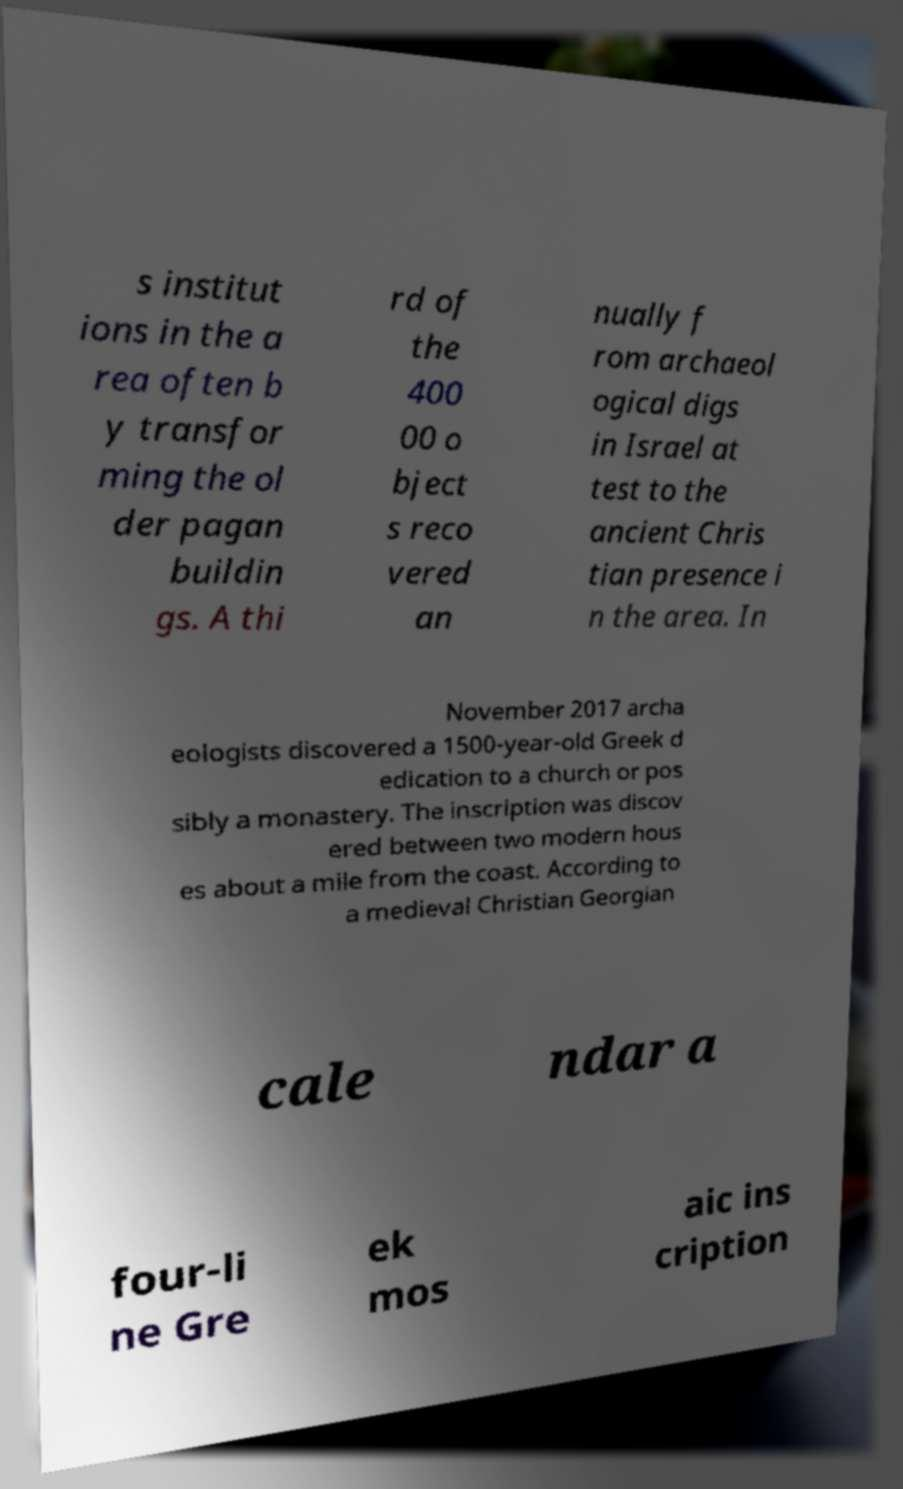What messages or text are displayed in this image? I need them in a readable, typed format. s institut ions in the a rea often b y transfor ming the ol der pagan buildin gs. A thi rd of the 400 00 o bject s reco vered an nually f rom archaeol ogical digs in Israel at test to the ancient Chris tian presence i n the area. In November 2017 archa eologists discovered a 1500-year-old Greek d edication to a church or pos sibly a monastery. The inscription was discov ered between two modern hous es about a mile from the coast. According to a medieval Christian Georgian cale ndar a four-li ne Gre ek mos aic ins cription 